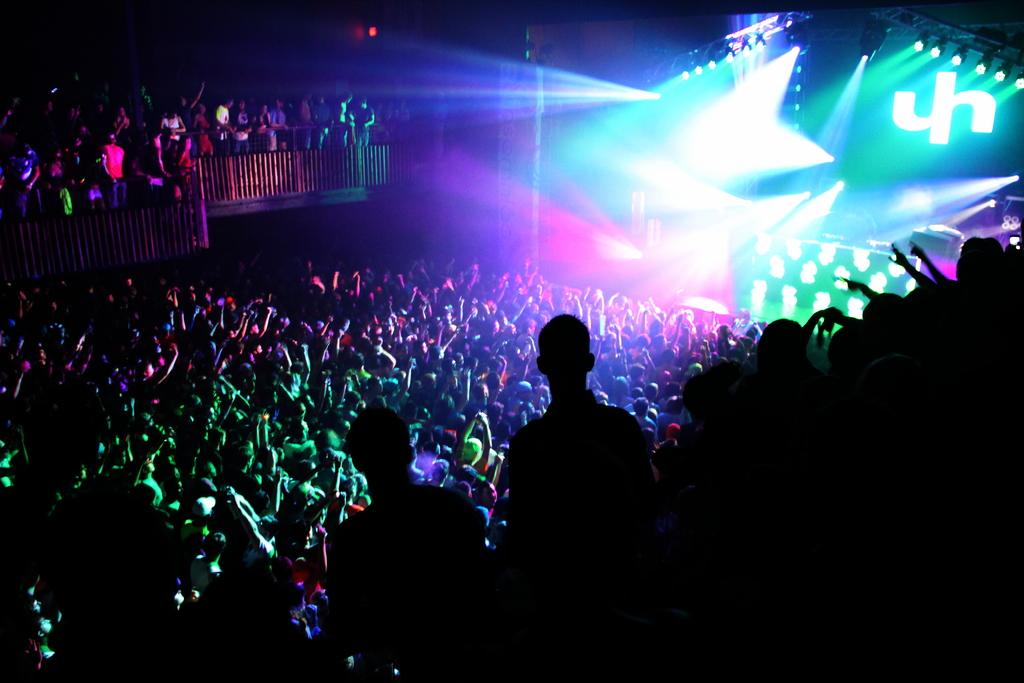What is located in the foreground of the image? There are people in the foreground of the image. What objects are present in the image that might be used for illumination? There are spotlights in the image. What type of setting is depicted in the image? It appears to be a stage in the image. What is visible in the background of the image? There are people in the background of the image. What type of sticks are being used by the people in the image? There are no sticks visible in the image; the people are not holding or using any sticks. 